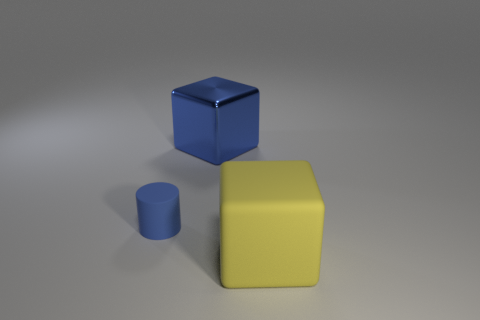Add 3 rubber objects. How many objects exist? 6 Subtract all blocks. How many objects are left? 1 Add 1 big gray matte blocks. How many big gray matte blocks exist? 1 Subtract 0 red cylinders. How many objects are left? 3 Subtract all large blue metallic cylinders. Subtract all blocks. How many objects are left? 1 Add 2 big blue shiny objects. How many big blue shiny objects are left? 3 